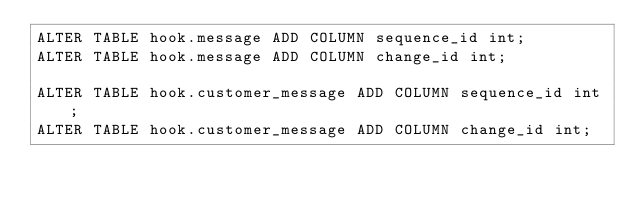<code> <loc_0><loc_0><loc_500><loc_500><_SQL_>ALTER TABLE hook.message ADD COLUMN sequence_id int;
ALTER TABLE hook.message ADD COLUMN change_id int;

ALTER TABLE hook.customer_message ADD COLUMN sequence_id int;
ALTER TABLE hook.customer_message ADD COLUMN change_id int;</code> 